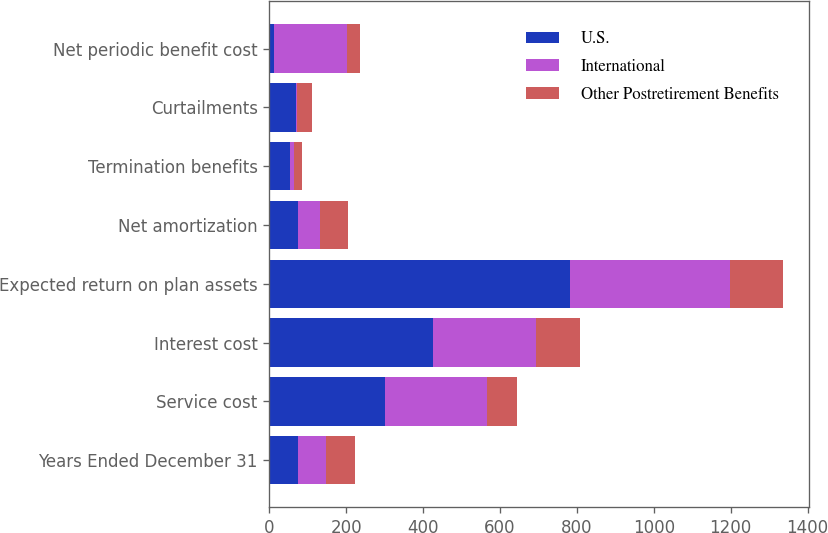Convert chart to OTSL. <chart><loc_0><loc_0><loc_500><loc_500><stacked_bar_chart><ecel><fcel>Years Ended December 31<fcel>Service cost<fcel>Interest cost<fcel>Expected return on plan assets<fcel>Net amortization<fcel>Termination benefits<fcel>Curtailments<fcel>Net periodic benefit cost<nl><fcel>U.S.<fcel>74<fcel>300<fcel>425<fcel>782<fcel>74<fcel>53<fcel>69<fcel>12<nl><fcel>International<fcel>74<fcel>266<fcel>269<fcel>416<fcel>59<fcel>11<fcel>4<fcel>191<nl><fcel>Other Postretirement Benefits<fcel>74<fcel>78<fcel>115<fcel>139<fcel>71<fcel>22<fcel>39<fcel>34<nl></chart> 